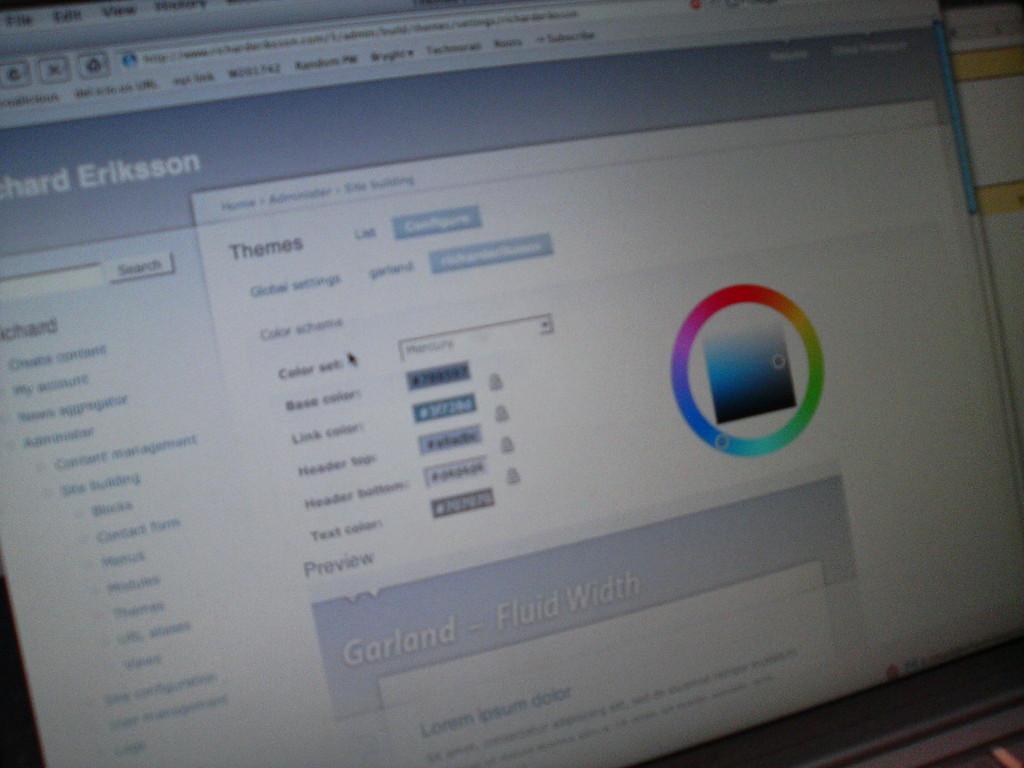What is the last name seen?
Your answer should be compact. Eriksson. What does the middle of the screen say?
Offer a very short reply. Garland - fluid width. 